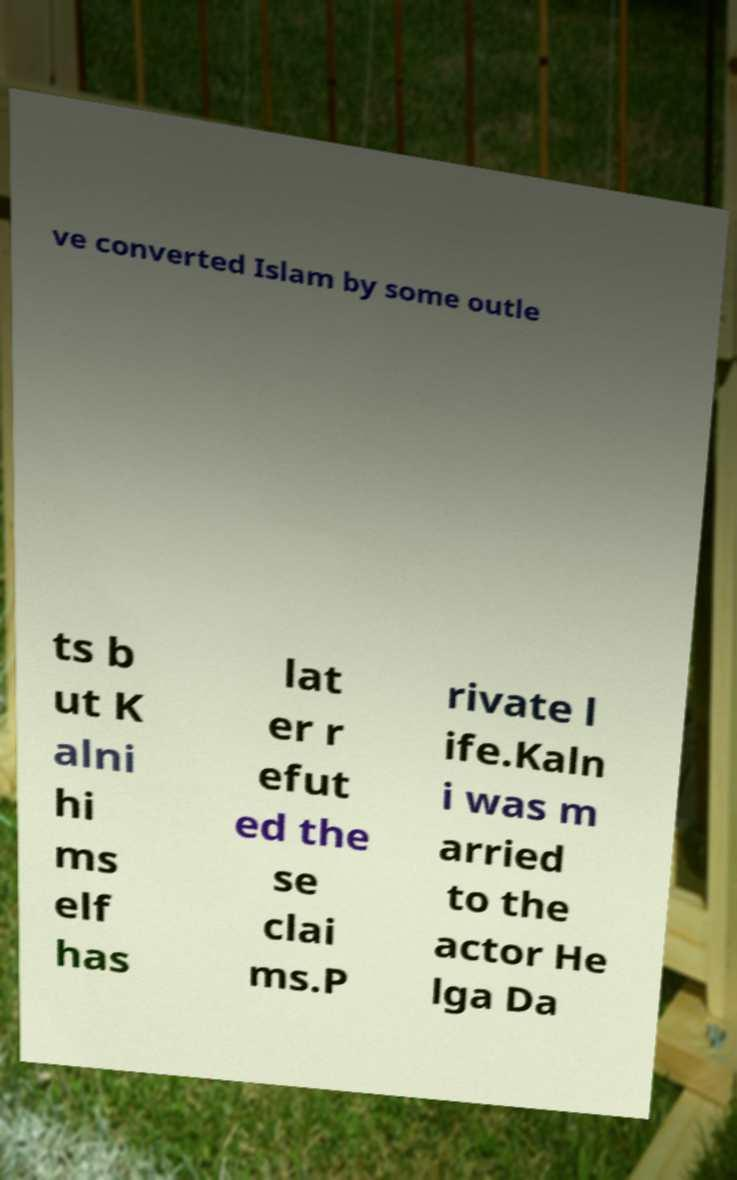Could you assist in decoding the text presented in this image and type it out clearly? ve converted Islam by some outle ts b ut K alni hi ms elf has lat er r efut ed the se clai ms.P rivate l ife.Kaln i was m arried to the actor He lga Da 